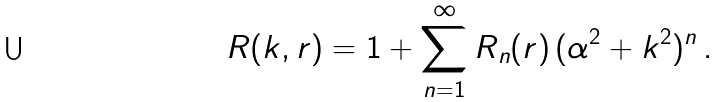<formula> <loc_0><loc_0><loc_500><loc_500>R ( k , r ) = 1 + \sum _ { n = 1 } ^ { \infty } R _ { n } ( r ) \, ( \alpha ^ { 2 } + k ^ { 2 } ) ^ { n } \, .</formula> 